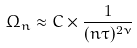<formula> <loc_0><loc_0><loc_500><loc_500>\Omega _ { n } \approx C \times \frac { 1 } { ( n \tau ) ^ { 2 \nu } }</formula> 